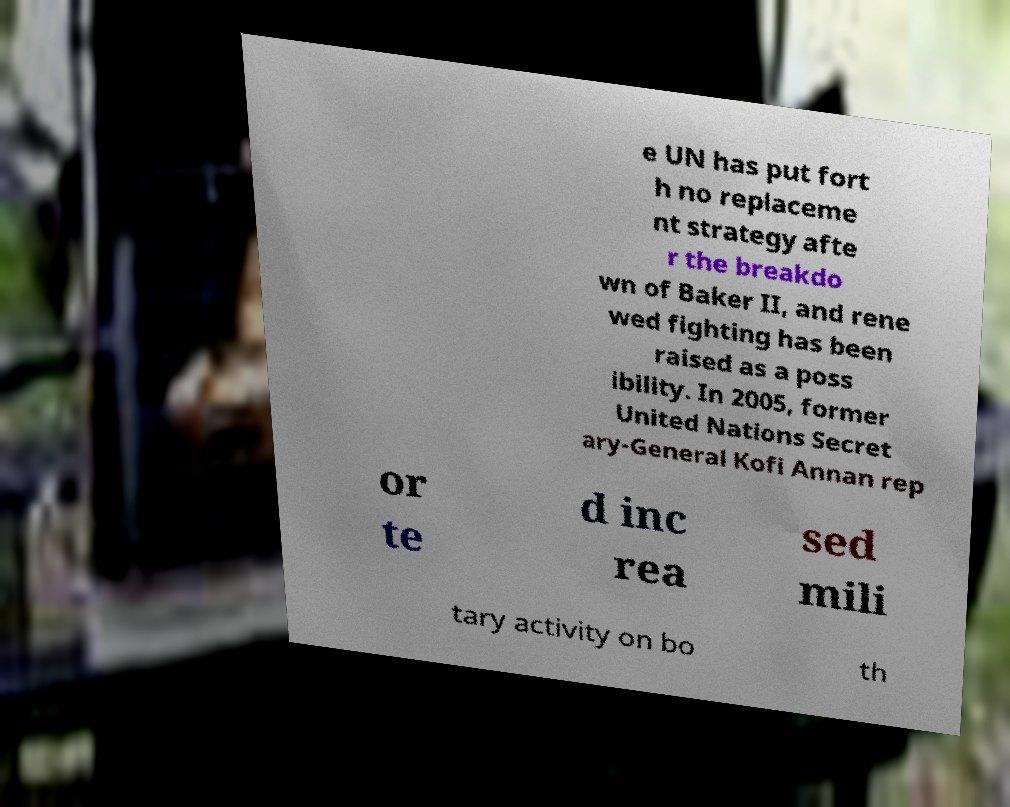I need the written content from this picture converted into text. Can you do that? e UN has put fort h no replaceme nt strategy afte r the breakdo wn of Baker II, and rene wed fighting has been raised as a poss ibility. In 2005, former United Nations Secret ary-General Kofi Annan rep or te d inc rea sed mili tary activity on bo th 